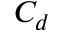<formula> <loc_0><loc_0><loc_500><loc_500>C _ { d }</formula> 